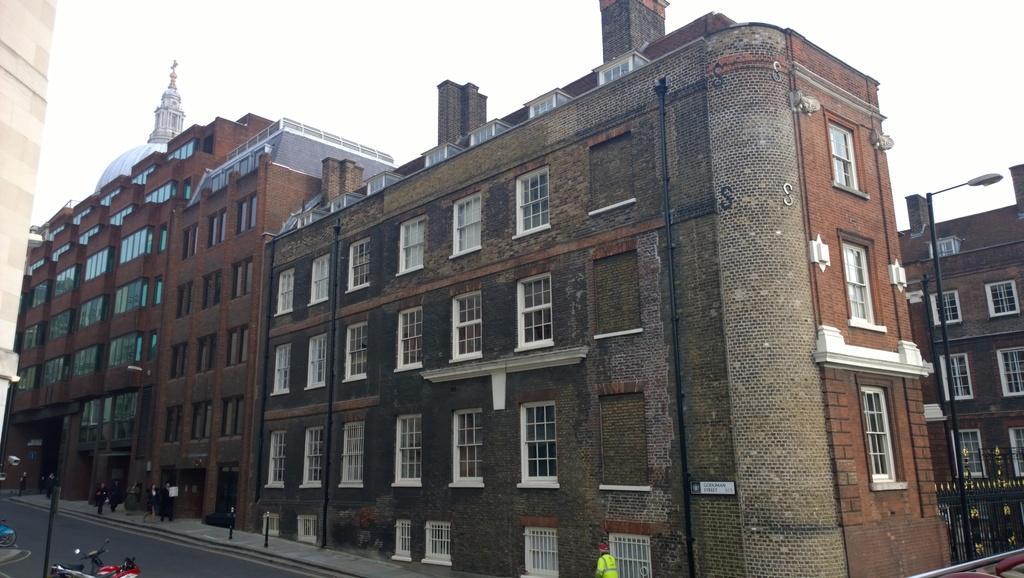Describe this image in one or two sentences. In this image we can see buildings, poles, people, board, road, and vehicles. In the background there is sky. 